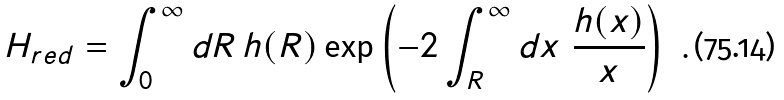Convert formula to latex. <formula><loc_0><loc_0><loc_500><loc_500>H _ { r e d } = \int _ { 0 } ^ { \infty } d R \, h ( R ) \exp \left ( - 2 \int _ { R } ^ { \infty } d x \ \frac { h ( x ) } { x } \right ) \ .</formula> 